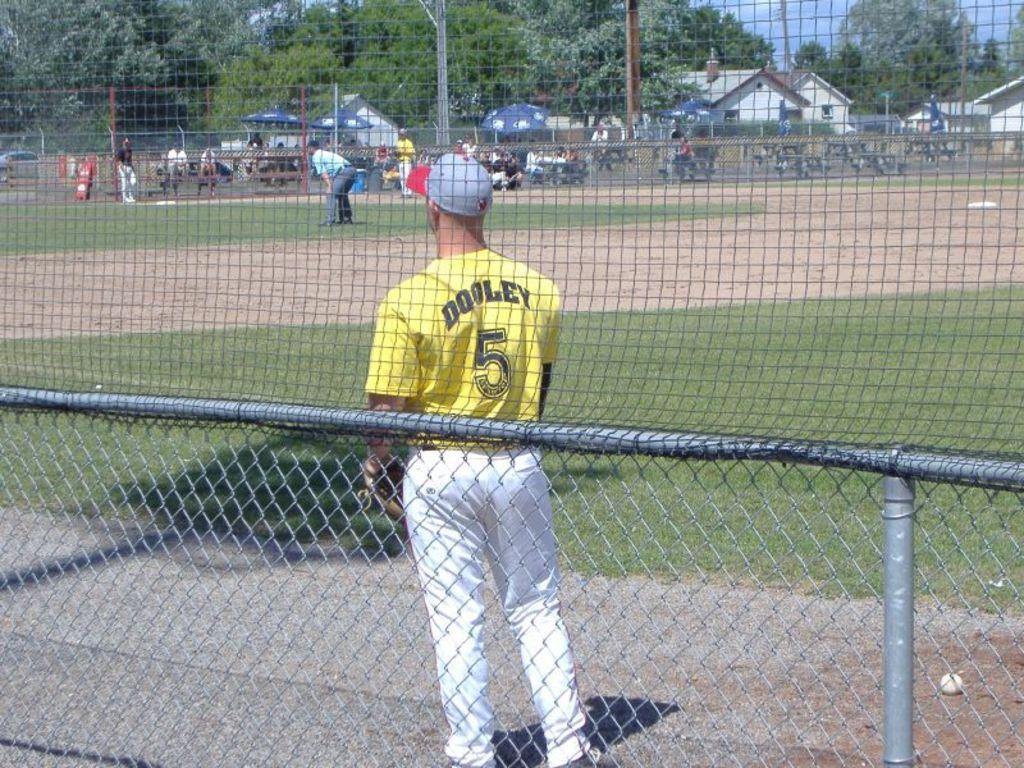What is the word on top of the number 5?
Give a very brief answer. Dooley. What is his number?
Provide a short and direct response. 5. 